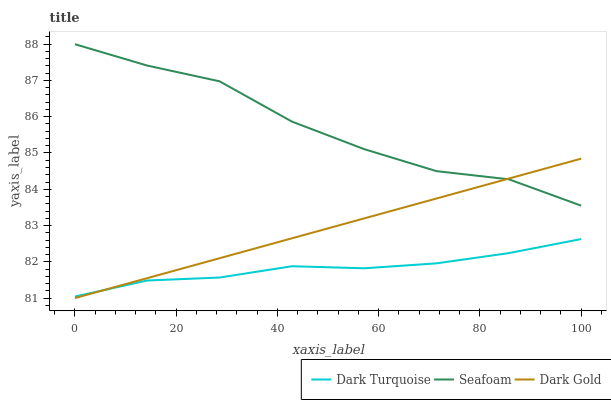Does Dark Turquoise have the minimum area under the curve?
Answer yes or no. Yes. Does Seafoam have the maximum area under the curve?
Answer yes or no. Yes. Does Dark Gold have the minimum area under the curve?
Answer yes or no. No. Does Dark Gold have the maximum area under the curve?
Answer yes or no. No. Is Dark Gold the smoothest?
Answer yes or no. Yes. Is Seafoam the roughest?
Answer yes or no. Yes. Is Seafoam the smoothest?
Answer yes or no. No. Is Dark Gold the roughest?
Answer yes or no. No. Does Seafoam have the lowest value?
Answer yes or no. No. Does Dark Gold have the highest value?
Answer yes or no. No. Is Dark Turquoise less than Seafoam?
Answer yes or no. Yes. Is Seafoam greater than Dark Turquoise?
Answer yes or no. Yes. Does Dark Turquoise intersect Seafoam?
Answer yes or no. No. 